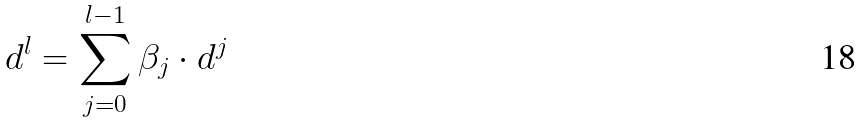<formula> <loc_0><loc_0><loc_500><loc_500>d ^ { l } = \sum _ { j = 0 } ^ { l - 1 } \beta _ { j } \cdot d ^ { j }</formula> 